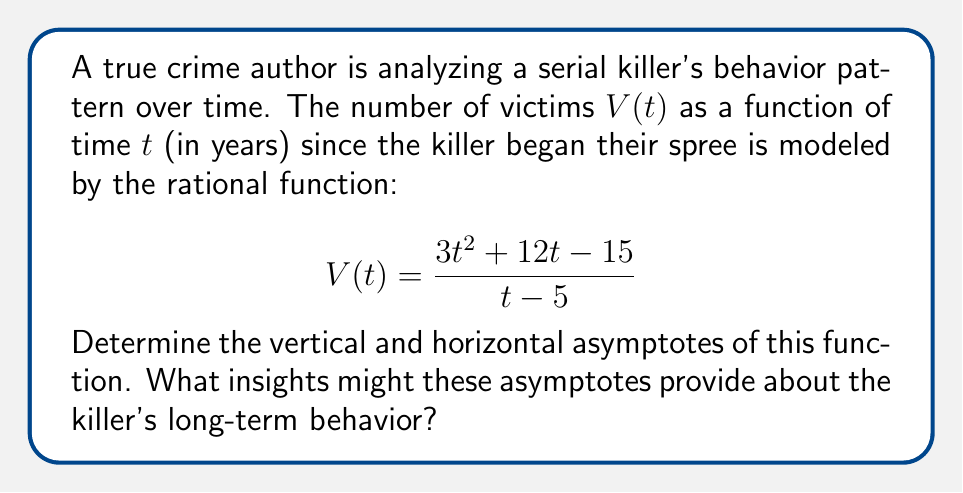Teach me how to tackle this problem. To find the asymptotes of the rational function, we'll follow these steps:

1) Vertical asymptote:
   The vertical asymptote occurs where the denominator equals zero.
   $t - 5 = 0$
   $t = 5$
   So, there is a vertical asymptote at $t = 5$.

2) Horizontal asymptote:
   To find the horizontal asymptote, we compare the degrees of the numerator and denominator.
   Degree of numerator: 2
   Degree of denominator: 1
   
   Since the degree of the numerator is greater than the degree of the denominator, there is no horizontal asymptote. Instead, we have a slant asymptote.

3) Slant asymptote:
   To find the slant asymptote, we perform polynomial long division:

   $$\frac{3t^2 + 12t - 15}{t - 5} = 3t + 27 + \frac{120}{t-5}$$

   The slant asymptote is $y = 3t + 27$.

Interpretation:
- The vertical asymptote at $t = 5$ suggests a dramatic change in behavior at the 5-year mark, possibly indicating a significant event or escalation in the killer's activities.
- The slant asymptote $y = 3t + 27$ implies that, in the long term, the number of victims increases linearly at a rate of 3 per year, with an offset of 27.
Answer: Vertical asymptote: $t = 5$; Slant asymptote: $y = 3t + 27$ 